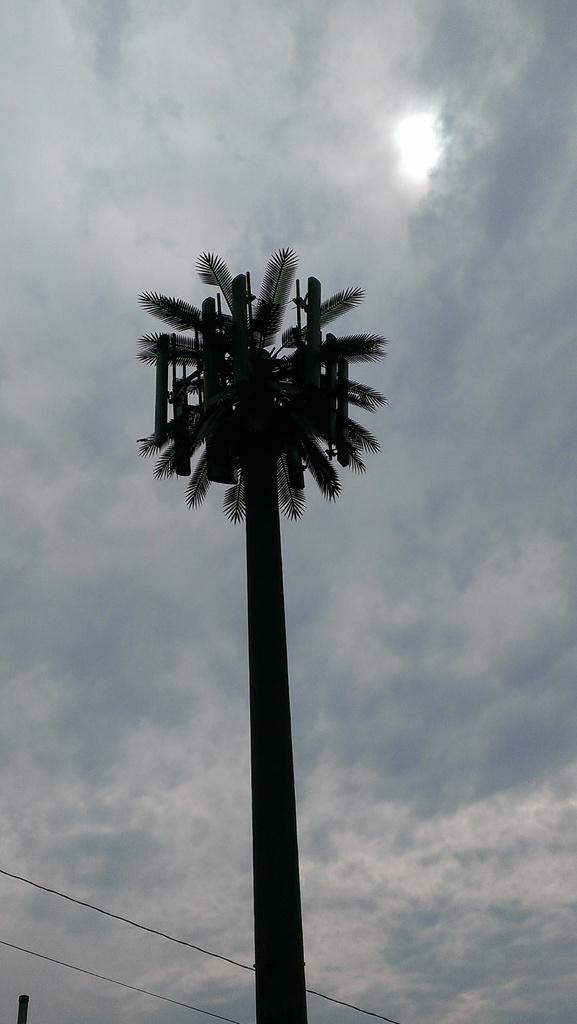What is located in the foreground of the image? There is a tree in the foreground of the image. What else can be seen in the image besides the tree? Cables are visible in the image. What part of the natural environment is visible in the image? The sky is visible in the image. Can you describe the sky in the image? There is a cloud in the sky. What type of amusement can be seen on the bridge in the image? There is no bridge or amusement present in the image. Can you tell me the credit limit of the person in the image? There is no person or credit limit mentioned in the image. 